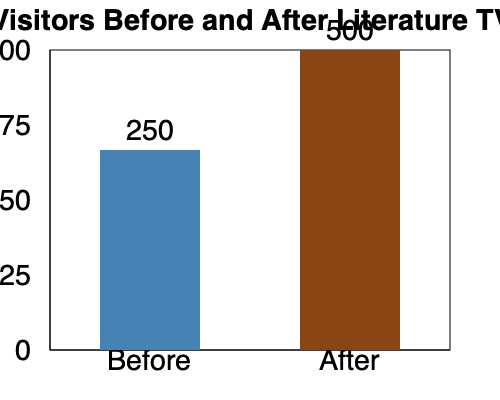In the context of the "golden era of television shows about literature," what was the percentage increase in library visitors after the introduction of these shows, and how might this reflect the impact of media on literary interest? To calculate the percentage increase in library visitors, we'll follow these steps:

1. Identify the number of visitors before and after:
   - Before: 250 visitors
   - After: 500 visitors

2. Calculate the difference:
   $500 - 250 = 250$ additional visitors

3. Calculate the percentage increase:
   Percentage increase = $\frac{\text{Increase}}{\text{Original}} \times 100\%$
   $= \frac{250}{250} \times 100\% = 100\%$

4. Interpret the results:
   The number of library visitors doubled after the introduction of literature-themed TV shows, indicating a 100% increase.

5. Reflect on the impact:
   This significant increase suggests that media representation of literature can have a powerful effect on public interest in reading and visiting libraries. The TV shows likely rekindled interest in classic works, introduced new audiences to literary masterpieces, and reminded people of the value of libraries as cultural institutions.

6. Consider the nostalgic perspective:
   For a retired librarian and French literature enthusiast, this increase would be particularly meaningful, as it represents a renaissance of interest in the literary world they cherish. It demonstrates that even in the modern age, classic literature can find new life through contemporary media adaptations.
Answer: 100% increase; media significantly boosted literary interest 